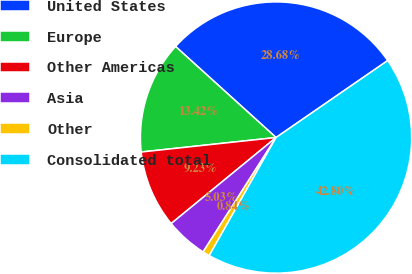<chart> <loc_0><loc_0><loc_500><loc_500><pie_chart><fcel>United States<fcel>Europe<fcel>Other Americas<fcel>Asia<fcel>Other<fcel>Consolidated total<nl><fcel>28.68%<fcel>13.42%<fcel>9.23%<fcel>5.03%<fcel>0.84%<fcel>42.8%<nl></chart> 